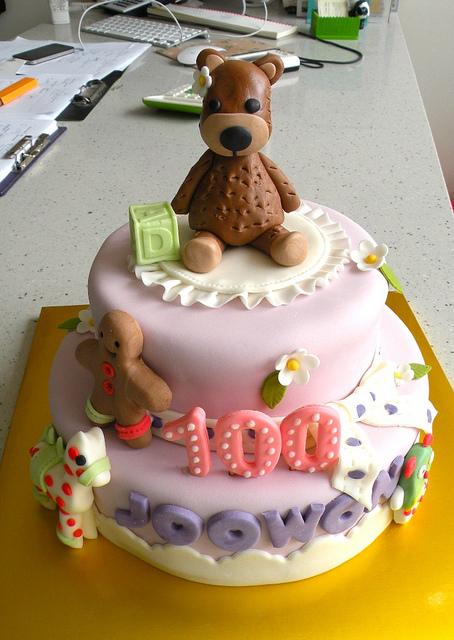What color is the fondant?
Short answer required. Pink. What is the cake sitting on?
Write a very short answer. Table. Is this a vase?
Keep it brief. No. What color is the bear?
Be succinct. Brown. What number is on cake?
Quick response, please. 100. What type of party would this cake be for?
Concise answer only. Birthday. What color is the doily under the cake?
Give a very brief answer. Yellow. 